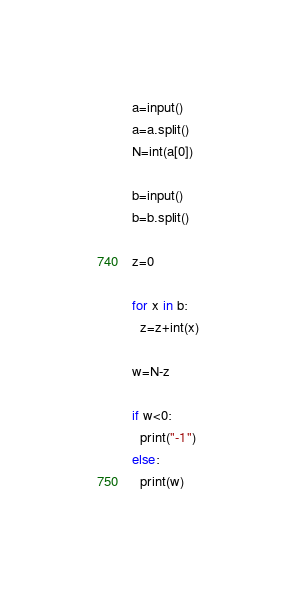<code> <loc_0><loc_0><loc_500><loc_500><_Python_>a=input()
a=a.split()
N=int(a[0])

b=input()
b=b.split()

z=0

for x in b:
  z=z+int(x)

w=N-z

if w<0:
  print("-1")
else:
  print(w)</code> 